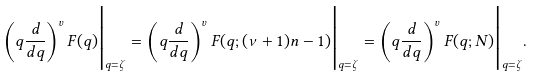Convert formula to latex. <formula><loc_0><loc_0><loc_500><loc_500>\left ( q \frac { d } { d q } \right ) ^ { v } F ( q ) \Big | _ { q = \zeta } = \left ( q \frac { d } { d q } \right ) ^ { v } F ( q ; ( \nu + 1 ) n - 1 ) \Big | _ { q = \zeta } = \left ( q \frac { d } { d q } \right ) ^ { v } F ( q ; N ) \Big | _ { q = \zeta } .</formula> 